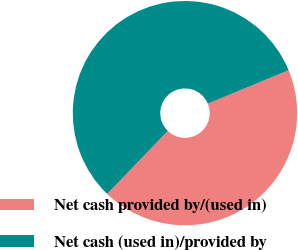Convert chart to OTSL. <chart><loc_0><loc_0><loc_500><loc_500><pie_chart><fcel>Net cash provided by/(used in)<fcel>Net cash (used in)/provided by<nl><fcel>43.45%<fcel>56.55%<nl></chart> 